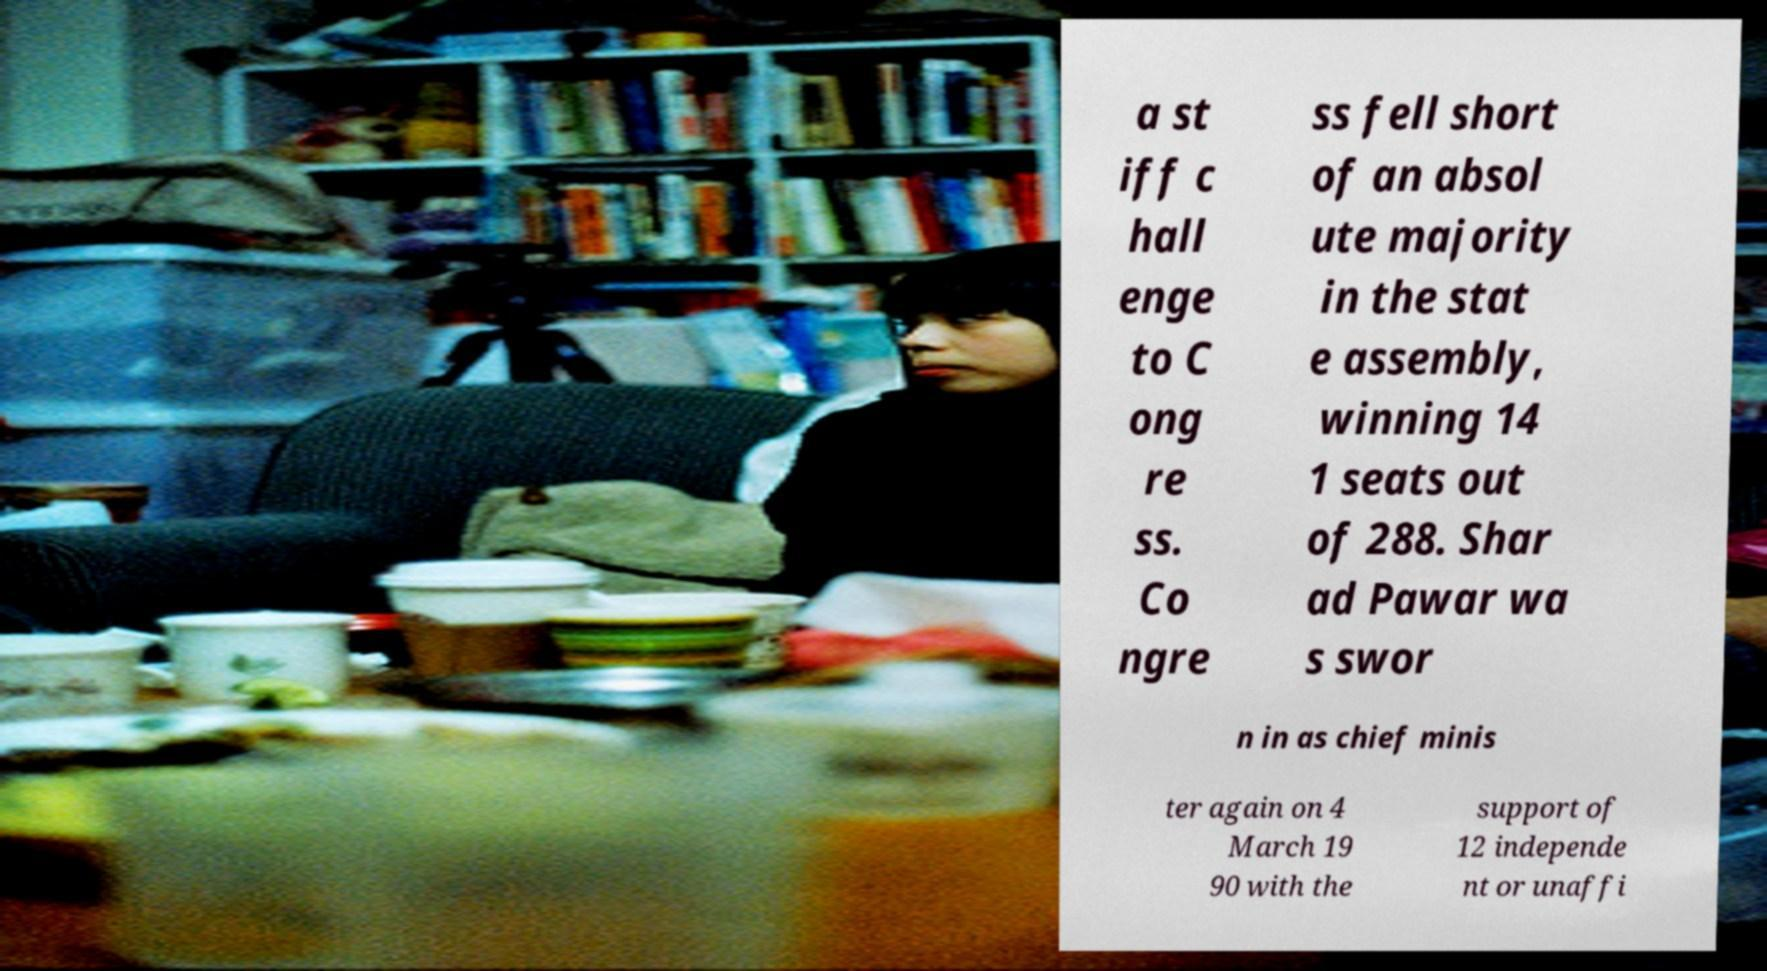What messages or text are displayed in this image? I need them in a readable, typed format. a st iff c hall enge to C ong re ss. Co ngre ss fell short of an absol ute majority in the stat e assembly, winning 14 1 seats out of 288. Shar ad Pawar wa s swor n in as chief minis ter again on 4 March 19 90 with the support of 12 independe nt or unaffi 